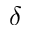<formula> <loc_0><loc_0><loc_500><loc_500>\delta</formula> 